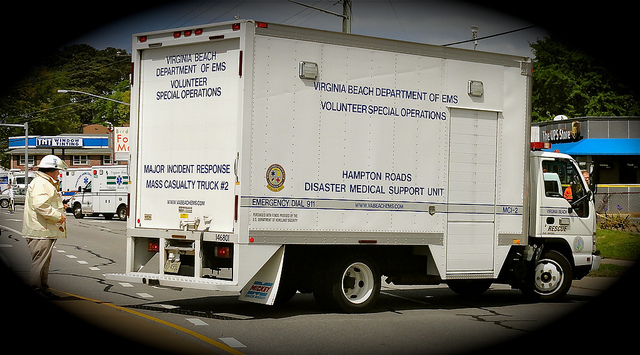<image>What is the website written on the van? It is unknown what is the website written on the van. What is the track transporting? I don't know what the track is transporting but it might be medical supplies. What is the track transporting? I am not sure what the track is transporting. It can be medical supplies, medical help, or disaster medical supplies. What is the website written on the van? I don't know what website is written on the van. It can be seen 'wwwnabeachemscom', 'wwwvbeachemscom' or 'wwwvirginiabeachemscom'. 